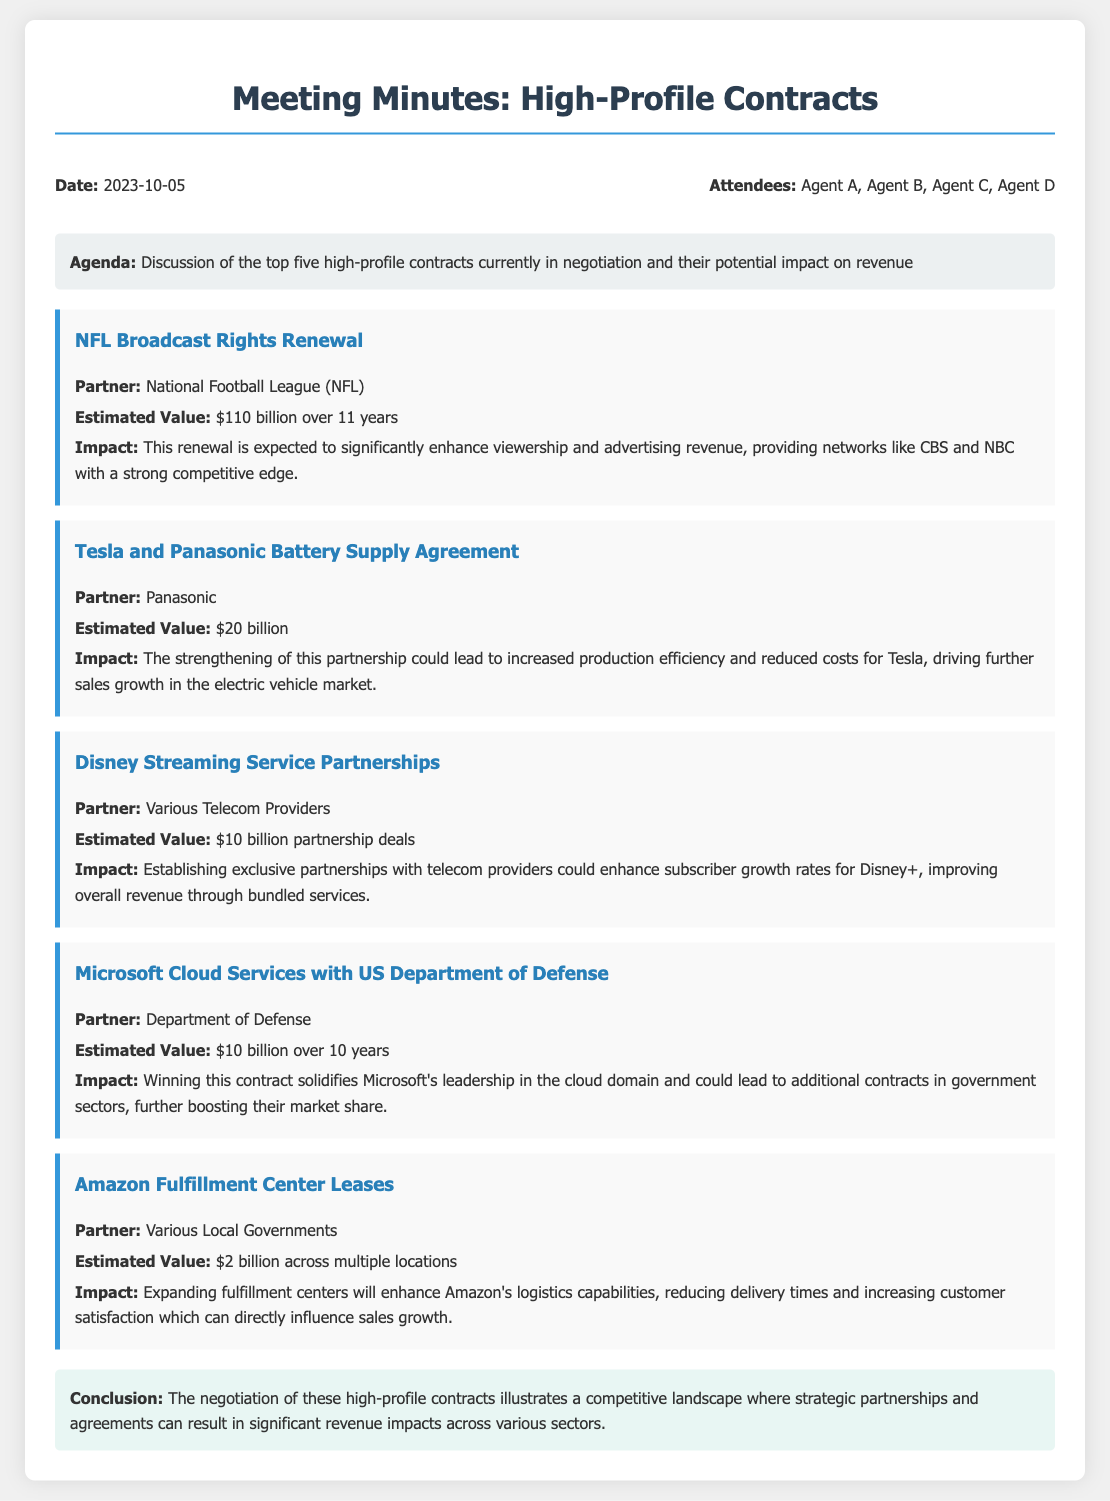what is the date of the meeting? The date of the meeting is indicated at the beginning of the document as the scheduled date for the discussions.
Answer: 2023-10-05 who attended the meeting? The document lists the attendees in a separate section, providing their names.
Answer: Agent A, Agent B, Agent C, Agent D what is the estimated value of the NFL Broadcast Rights Renewal? The document states the estimated value of this contract among the top five high-profile contracts in negotiation, providing a specific amount.
Answer: $110 billion which contract has an estimated value of $20 billion? The document lists several contracts and specifies that this particular estimated value corresponds to a partnership with Panasonic.
Answer: Tesla and Panasonic Battery Supply Agreement how long is the contract period for the Microsoft Cloud Services with the US Department of Defense? The document specifies the duration of this contract in its details, indicating how many years it spans.
Answer: 10 years what is the potential impact of Disney Streaming Service Partnerships? The document describes the expected outcome of this partnership, focusing on subscriber growth and revenue improvement.
Answer: Subscriber growth rates which company's fulfillment center leases are valued at $2 billion? The document explicitly mentions the partner responsible for the fulfillment center leases and their associated contract value.
Answer: Amazon what is the main benefit of the Tesla and Panasonic partnership? The document summarizes the advantages expected from this contract, focusing on production efficiency and cost.
Answer: Increased production efficiency what is the estimated value of the contracts mentioned in the document? The document outlines the estimated values of each contract, and this question seeks the total sum of these amounts.
Answer: $152 billion 